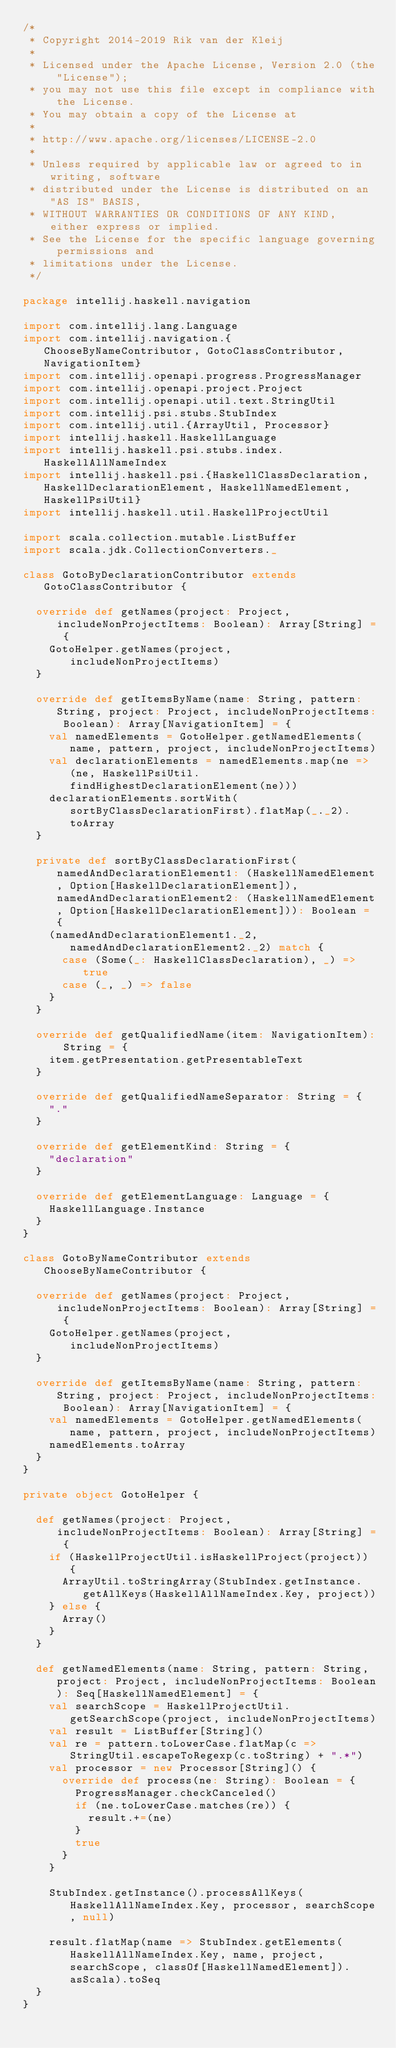<code> <loc_0><loc_0><loc_500><loc_500><_Scala_>/*
 * Copyright 2014-2019 Rik van der Kleij
 *
 * Licensed under the Apache License, Version 2.0 (the "License");
 * you may not use this file except in compliance with the License.
 * You may obtain a copy of the License at
 *
 * http://www.apache.org/licenses/LICENSE-2.0
 *
 * Unless required by applicable law or agreed to in writing, software
 * distributed under the License is distributed on an "AS IS" BASIS,
 * WITHOUT WARRANTIES OR CONDITIONS OF ANY KIND, either express or implied.
 * See the License for the specific language governing permissions and
 * limitations under the License.
 */

package intellij.haskell.navigation

import com.intellij.lang.Language
import com.intellij.navigation.{ChooseByNameContributor, GotoClassContributor, NavigationItem}
import com.intellij.openapi.progress.ProgressManager
import com.intellij.openapi.project.Project
import com.intellij.openapi.util.text.StringUtil
import com.intellij.psi.stubs.StubIndex
import com.intellij.util.{ArrayUtil, Processor}
import intellij.haskell.HaskellLanguage
import intellij.haskell.psi.stubs.index.HaskellAllNameIndex
import intellij.haskell.psi.{HaskellClassDeclaration, HaskellDeclarationElement, HaskellNamedElement, HaskellPsiUtil}
import intellij.haskell.util.HaskellProjectUtil

import scala.collection.mutable.ListBuffer
import scala.jdk.CollectionConverters._

class GotoByDeclarationContributor extends GotoClassContributor {

  override def getNames(project: Project, includeNonProjectItems: Boolean): Array[String] = {
    GotoHelper.getNames(project, includeNonProjectItems)
  }

  override def getItemsByName(name: String, pattern: String, project: Project, includeNonProjectItems: Boolean): Array[NavigationItem] = {
    val namedElements = GotoHelper.getNamedElements(name, pattern, project, includeNonProjectItems)
    val declarationElements = namedElements.map(ne => (ne, HaskellPsiUtil.findHighestDeclarationElement(ne)))
    declarationElements.sortWith(sortByClassDeclarationFirst).flatMap(_._2).toArray
  }

  private def sortByClassDeclarationFirst(namedAndDeclarationElement1: (HaskellNamedElement, Option[HaskellDeclarationElement]), namedAndDeclarationElement2: (HaskellNamedElement, Option[HaskellDeclarationElement])): Boolean = {
    (namedAndDeclarationElement1._2, namedAndDeclarationElement2._2) match {
      case (Some(_: HaskellClassDeclaration), _) => true
      case (_, _) => false
    }
  }

  override def getQualifiedName(item: NavigationItem): String = {
    item.getPresentation.getPresentableText
  }

  override def getQualifiedNameSeparator: String = {
    "."
  }

  override def getElementKind: String = {
    "declaration"
  }

  override def getElementLanguage: Language = {
    HaskellLanguage.Instance
  }
}

class GotoByNameContributor extends ChooseByNameContributor {

  override def getNames(project: Project, includeNonProjectItems: Boolean): Array[String] = {
    GotoHelper.getNames(project, includeNonProjectItems)
  }

  override def getItemsByName(name: String, pattern: String, project: Project, includeNonProjectItems: Boolean): Array[NavigationItem] = {
    val namedElements = GotoHelper.getNamedElements(name, pattern, project, includeNonProjectItems)
    namedElements.toArray
  }
}

private object GotoHelper {

  def getNames(project: Project, includeNonProjectItems: Boolean): Array[String] = {
    if (HaskellProjectUtil.isHaskellProject(project)) {
      ArrayUtil.toStringArray(StubIndex.getInstance.getAllKeys(HaskellAllNameIndex.Key, project))
    } else {
      Array()
    }
  }

  def getNamedElements(name: String, pattern: String, project: Project, includeNonProjectItems: Boolean): Seq[HaskellNamedElement] = {
    val searchScope = HaskellProjectUtil.getSearchScope(project, includeNonProjectItems)
    val result = ListBuffer[String]()
    val re = pattern.toLowerCase.flatMap(c => StringUtil.escapeToRegexp(c.toString) + ".*")
    val processor = new Processor[String]() {
      override def process(ne: String): Boolean = {
        ProgressManager.checkCanceled()
        if (ne.toLowerCase.matches(re)) {
          result.+=(ne)
        }
        true
      }
    }

    StubIndex.getInstance().processAllKeys(HaskellAllNameIndex.Key, processor, searchScope, null)

    result.flatMap(name => StubIndex.getElements(HaskellAllNameIndex.Key, name, project, searchScope, classOf[HaskellNamedElement]).asScala).toSeq
  }
}</code> 